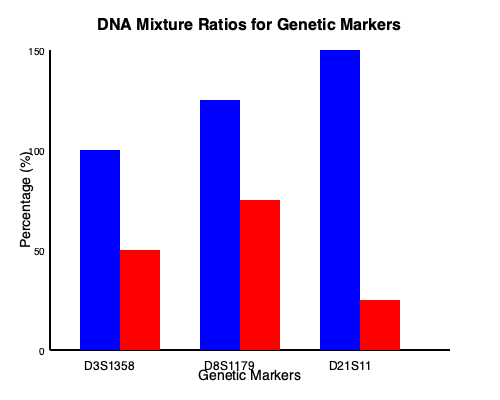Based on the DNA mixture ratio bar graph for genetic markers D3S1358, D8S1179, and D21S11, what is the approximate mixture ratio of the major (blue) to minor (red) contributor for the D21S11 marker? Express your answer as a ratio in the form x:y. To determine the mixture ratio for the D21S11 marker, we need to follow these steps:

1. Identify the D21S11 marker on the graph (rightmost set of bars).
2. Estimate the height of the blue (major contributor) and red (minor contributor) bars.
3. Convert the heights to percentages based on the y-axis scale.
4. Express the ratio of the major to minor contributor.

For the D21S11 marker:

1. The blue bar extends from 0% to approximately 150%.
2. The red bar extends from approximately 150% to 175%.

To calculate the percentages:
- Major contributor (blue): 150% - 0% = 150%
- Minor contributor (red): 175% - 150% = 25%

Now, we can express this as a ratio:
$\frac{150}{25} = 6$

This means for every 6 parts of the major contributor, there is 1 part of the minor contributor.

Therefore, the approximate mixture ratio of major to minor contributor for D21S11 is 6:1.
Answer: 6:1 